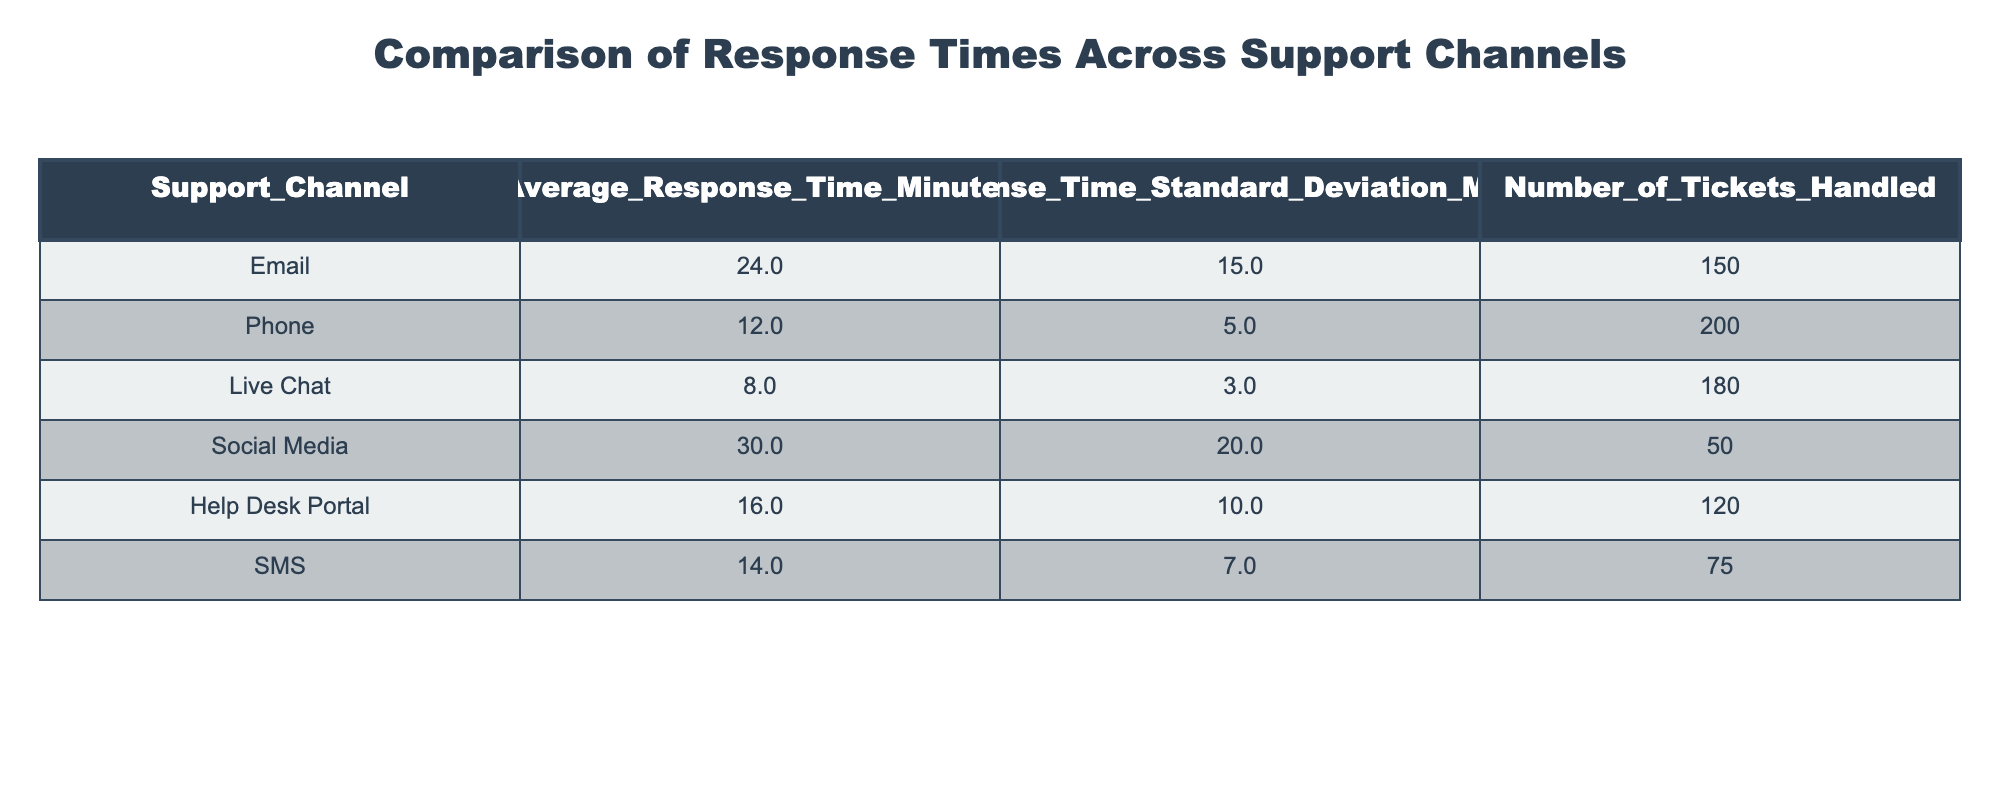What is the average response time for the Live Chat support channel? The table indicates that the average response time for the Live Chat channel is 8 minutes.
Answer: 8 minutes Which support channel has the highest average response time? Upon reviewing the table, the Social Media channel has the highest average response time, recorded at 30 minutes.
Answer: Social Media What is the difference in average response time between Phone and SMS channels? The average response time for Phone is 12 minutes, and for SMS, it is 14 minutes. The difference is calculated as 14 - 12 = 2 minutes.
Answer: 2 minutes Is the average response time for Email greater than 20 minutes? The table shows that the average response time for Email is 24 minutes, which is greater than 20 minutes. Therefore, the answer is yes.
Answer: Yes What is the total number of tickets handled across all support channels? To find the total number of tickets handled, sum the values from the "Number_of_Tickets_Handled" column: 150 + 200 + 180 + 50 + 120 + 75 = 775.
Answer: 775 Which channel has the lowest standard deviation in response time? The standard deviations for the channels are: Email (15), Phone (5), Live Chat (3), Social Media (20), Help Desk Portal (10), and SMS (7). The lowest standard deviation is 3 for Live Chat.
Answer: Live Chat If we average the average response times of the Email and Help Desk Portal, what do we get? The average response time for Email is 24 minutes, and for Help Desk Portal it's 16 minutes. Their average is (24 + 16) / 2 = 20 minutes.
Answer: 20 minutes Is it true that the Phone and SMS channels have lower average response times than the Help Desk Portal? The Phone channel has an average response time of 12 minutes and SMS 14 minutes, both are lower than Help Desk Portal's 16 minutes. Therefore, the statement is true.
Answer: True How many more tickets were handled via Phone compared to Social Media? The Phone channel handled 200 tickets while the Social Media handled 50 tickets. The difference is 200 - 50 = 150 tickets.
Answer: 150 tickets 